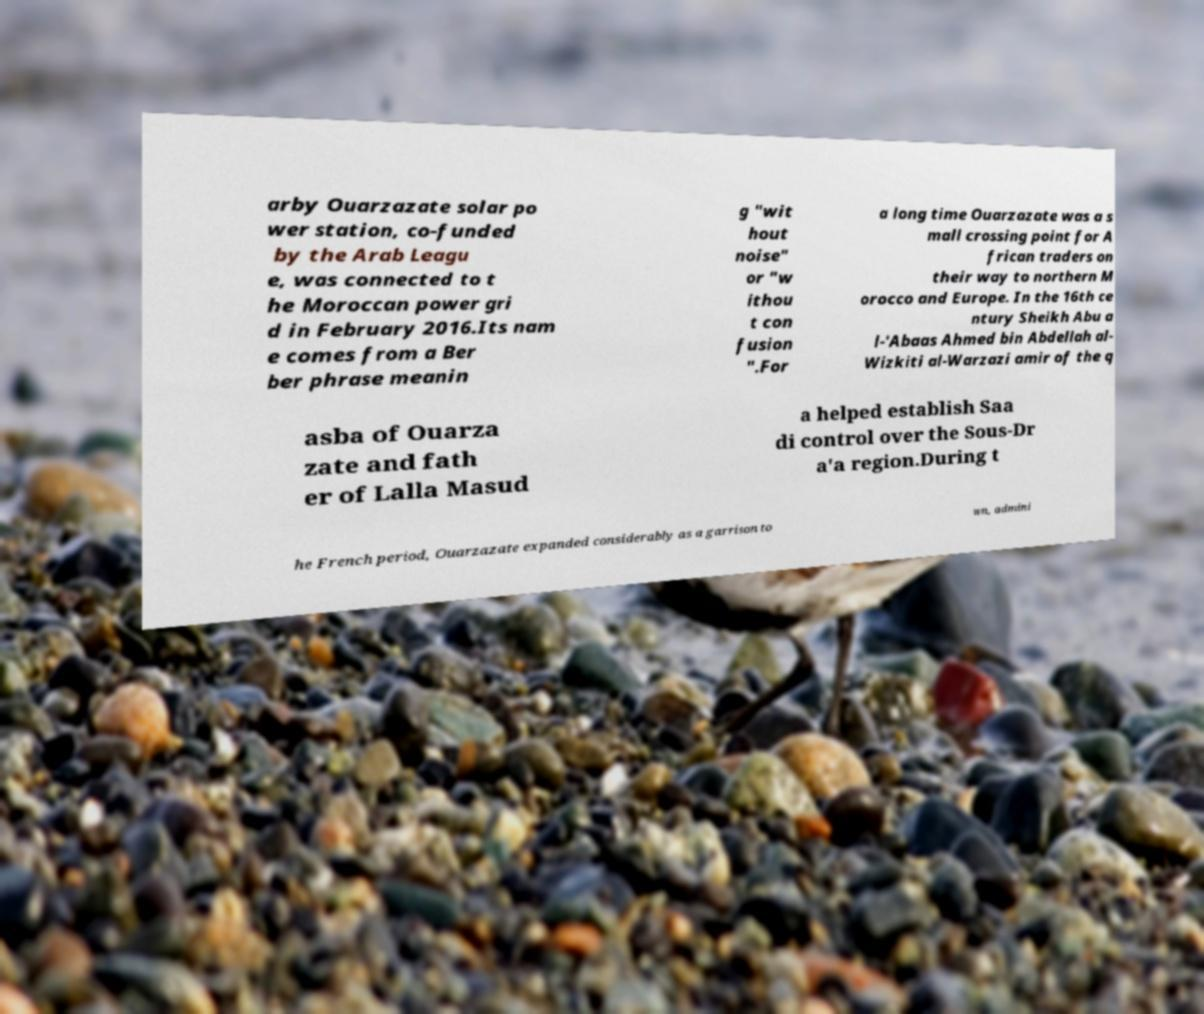Could you extract and type out the text from this image? arby Ouarzazate solar po wer station, co-funded by the Arab Leagu e, was connected to t he Moroccan power gri d in February 2016.Its nam e comes from a Ber ber phrase meanin g "wit hout noise" or "w ithou t con fusion ".For a long time Ouarzazate was a s mall crossing point for A frican traders on their way to northern M orocco and Europe. In the 16th ce ntury Sheikh Abu a l-'Abaas Ahmed bin Abdellah al- Wizkiti al-Warzazi amir of the q asba of Ouarza zate and fath er of Lalla Masud a helped establish Saa di control over the Sous-Dr a'a region.During t he French period, Ouarzazate expanded considerably as a garrison to wn, admini 